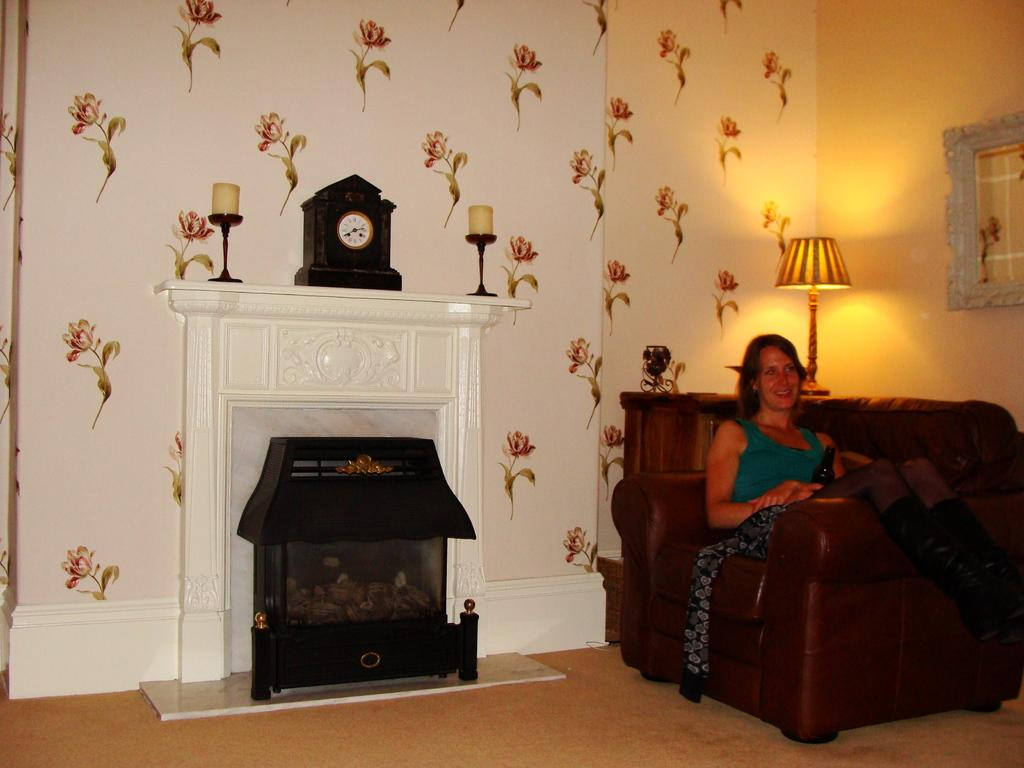What is the woman doing in the image? The woman is sitting on a chair in the image. What can be seen in the background of the image? There is a fireplace in the image. What time-related object is present in the image? There is a clock in the image. What type of lighting is present in the image? There are candles in the image. What is attached to the wall in the image? There are objects attached to the wall in the image. What type of straw is being used for the meeting in the image? There is no straw or meeting present in the image. What type of fruit is being served at the quince in the image? There is no quince or fruit being served in the image. 